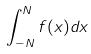Convert formula to latex. <formula><loc_0><loc_0><loc_500><loc_500>\int _ { - N } ^ { N } f ( x ) d x</formula> 